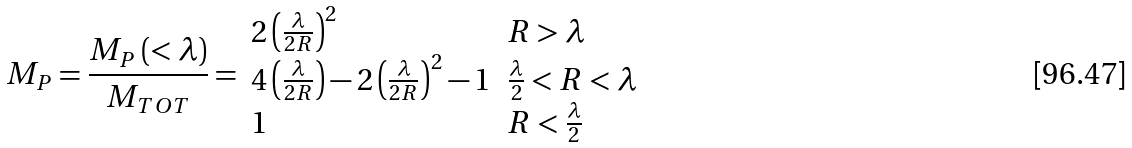<formula> <loc_0><loc_0><loc_500><loc_500>M _ { P } = \frac { M _ { P } \left ( < \lambda \right ) } { M _ { T O T } } = \begin{array} { l l } 2 \left ( \frac { \lambda } { 2 R } \right ) ^ { 2 } & R > \lambda \\ 4 \left ( \frac { \lambda } { 2 R } \right ) - 2 \left ( \frac { \lambda } { 2 R } \right ) ^ { 2 } - 1 & \frac { \lambda } { 2 } < R < \lambda \\ 1 & R < \frac { \lambda } { 2 } \end{array}</formula> 